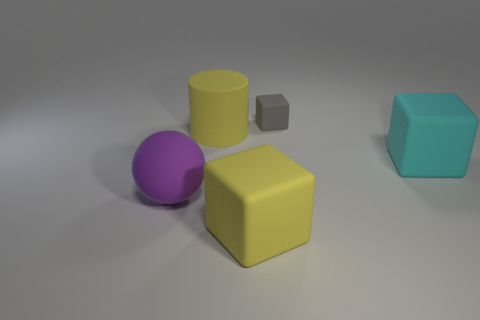Add 4 small blue rubber cylinders. How many objects exist? 9 Subtract all cubes. How many objects are left? 2 Subtract 0 green blocks. How many objects are left? 5 Subtract all tiny cyan cubes. Subtract all yellow blocks. How many objects are left? 4 Add 3 big yellow blocks. How many big yellow blocks are left? 4 Add 2 blue matte cubes. How many blue matte cubes exist? 2 